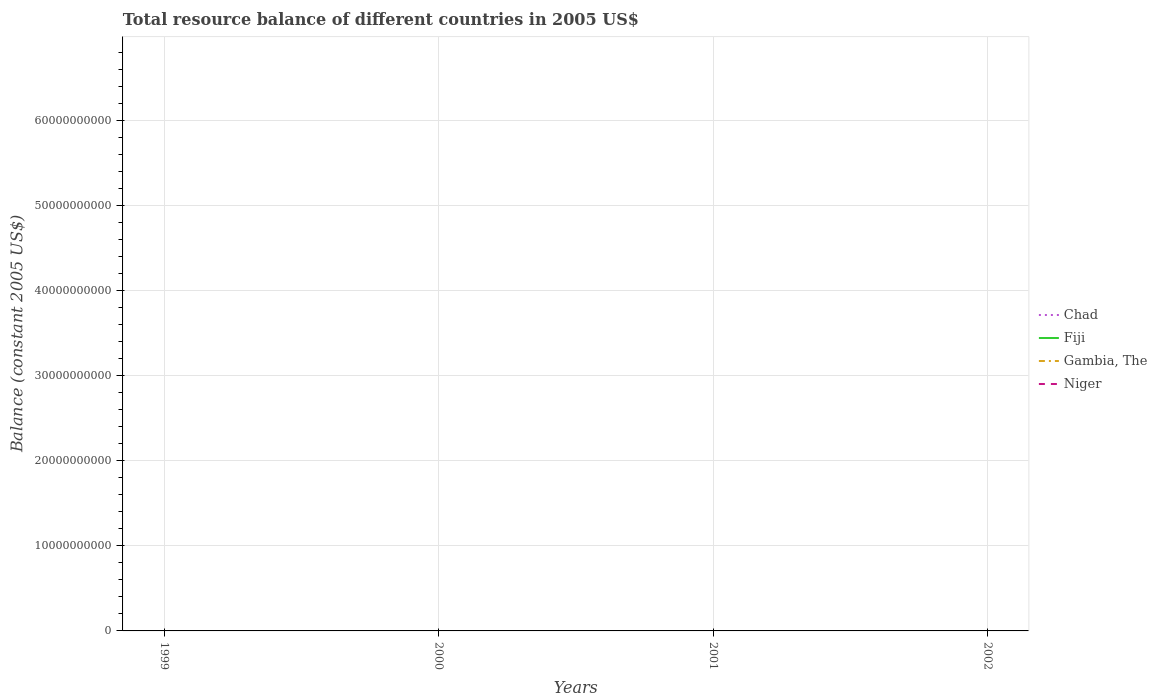Across all years, what is the maximum total resource balance in Chad?
Your answer should be compact. 0. What is the difference between the highest and the lowest total resource balance in Gambia, The?
Provide a succinct answer. 0. What is the difference between two consecutive major ticks on the Y-axis?
Your answer should be compact. 1.00e+1. Does the graph contain any zero values?
Keep it short and to the point. Yes. Where does the legend appear in the graph?
Provide a short and direct response. Center right. What is the title of the graph?
Ensure brevity in your answer.  Total resource balance of different countries in 2005 US$. What is the label or title of the Y-axis?
Make the answer very short. Balance (constant 2005 US$). What is the Balance (constant 2005 US$) of Chad in 1999?
Your response must be concise. 0. What is the Balance (constant 2005 US$) in Niger in 1999?
Offer a very short reply. 0. What is the Balance (constant 2005 US$) of Fiji in 2000?
Offer a terse response. 0. What is the Balance (constant 2005 US$) in Gambia, The in 2000?
Your response must be concise. 0. What is the Balance (constant 2005 US$) in Niger in 2000?
Offer a very short reply. 0. What is the Balance (constant 2005 US$) in Fiji in 2001?
Make the answer very short. 0. What is the Balance (constant 2005 US$) of Chad in 2002?
Provide a succinct answer. 0. What is the Balance (constant 2005 US$) of Fiji in 2002?
Provide a succinct answer. 0. What is the Balance (constant 2005 US$) of Gambia, The in 2002?
Make the answer very short. 0. What is the total Balance (constant 2005 US$) in Chad in the graph?
Ensure brevity in your answer.  0. What is the total Balance (constant 2005 US$) of Gambia, The in the graph?
Your answer should be compact. 0. What is the average Balance (constant 2005 US$) in Fiji per year?
Give a very brief answer. 0. What is the average Balance (constant 2005 US$) in Gambia, The per year?
Your answer should be compact. 0. 